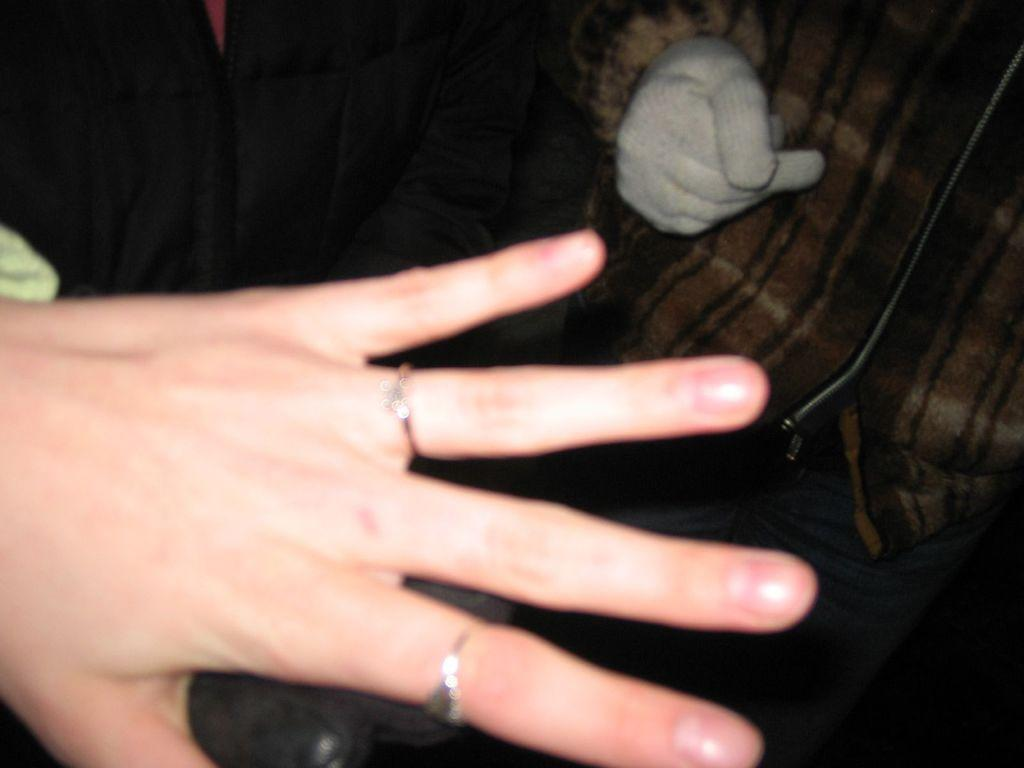What can be seen in the foreground of the image? There is a person's hand with rings in the image. Can you describe the person in the background of the image? The second person is wearing a dress and gloves. What is the second person doing in the image? The provided facts do not specify what the second person is doing, but we can see that they are present in the background. What type of cub can be seen playing with a parcel in the image? There is no cub or parcel present in the image. 